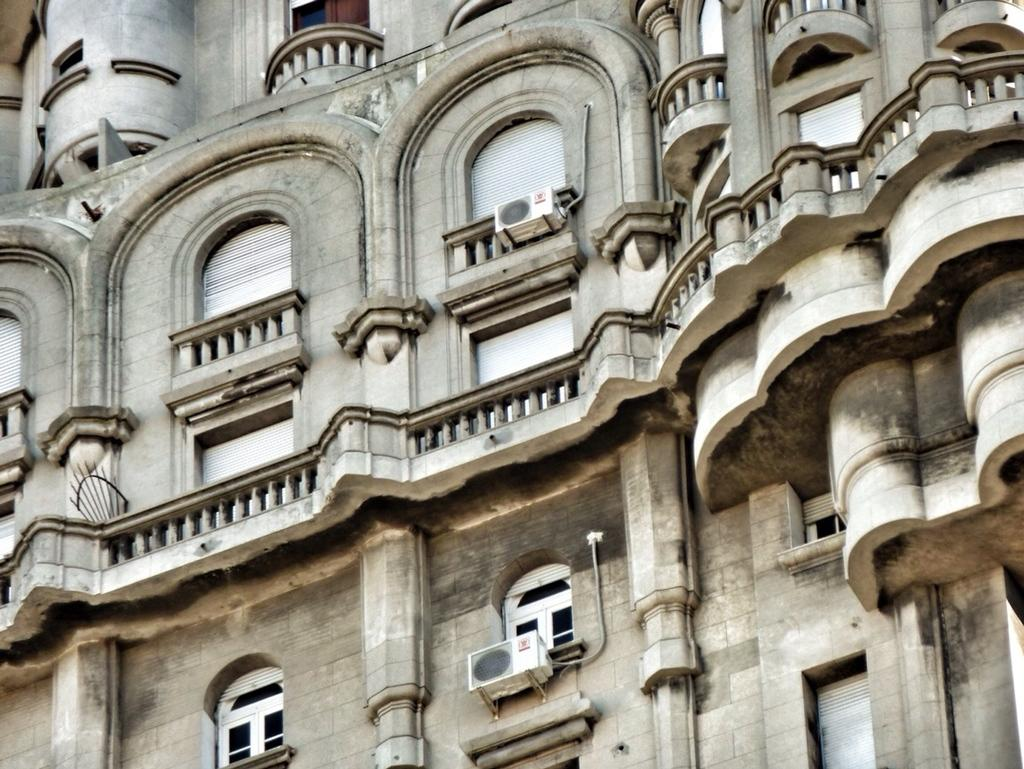Where was the image taken? The image is taken outdoors. What can be seen in the background of the image? There is a building in the image. What are some features of the building? The building has walls, windows, railings, balconies, and air conditioners. What type of range can be seen in the image? There is no range present in the image; it features a building with various features. What day is depicted in the image? The image does not depict a specific day; it is a still photograph of a building. 